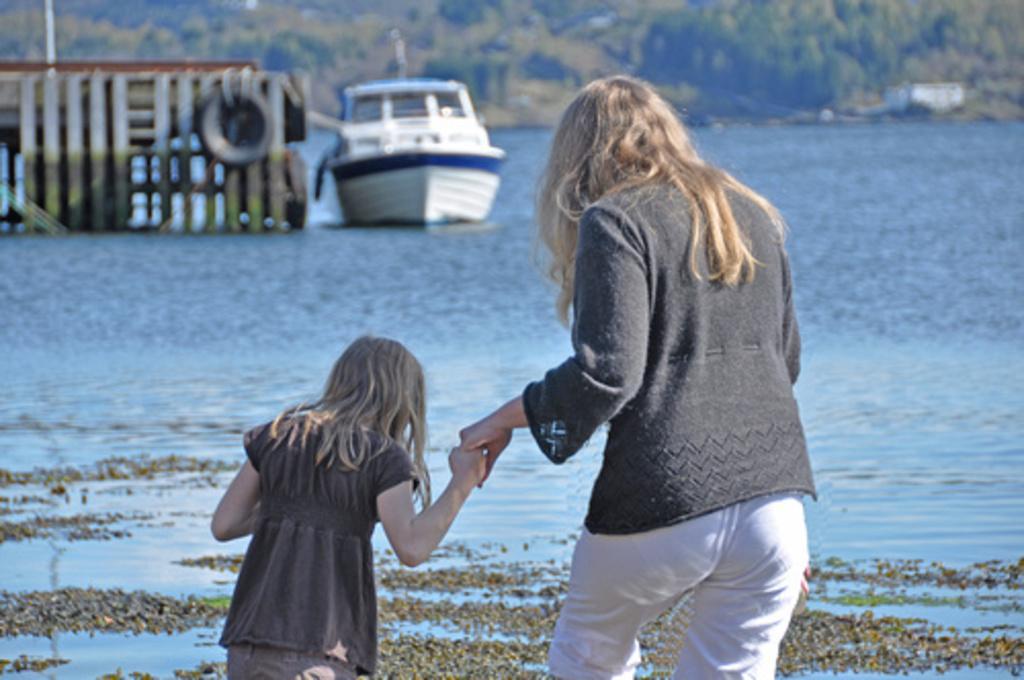In one or two sentences, can you explain what this image depicts? Background portion of the picture is blurry and we can see the trees. In this picture we can see a boat, bridge, tyre tied with a rope, wooden planks. At the bottom portion of the picture we can see a woman holding the hand of a girl. They are near to the sea shore. 